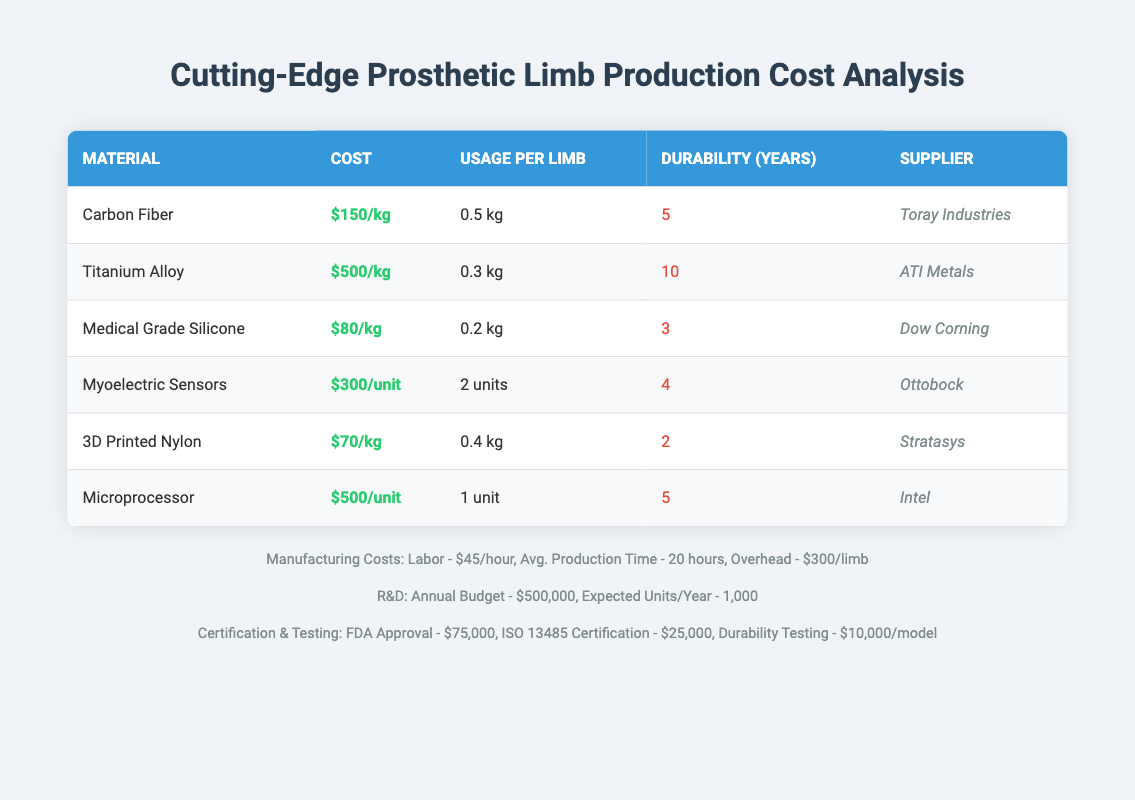What is the cost of Carbon Fiber per kilogram? The table shows that the cost of Carbon Fiber is listed as $150/kg.
Answer: $150/kg How much Medical Grade Silicone is used on average per limb? According to the table, the average usage of Medical Grade Silicone per limb is 0.2 kg.
Answer: 0.2 kg How many units of Myoelectric Sensors are required for each limb? The table indicates that 2 units of Myoelectric Sensors are required for each prosthetic limb.
Answer: 2 units What is the total cost of materials for Titanium Alloy used in one limb? To find the total cost of Titanium Alloy: Cost per kg is $500, and average usage per limb is 0.3 kg, so total cost = 500 * 0.3 = $150.
Answer: $150 What is the total durability in years of all materials used in a single prosthetic limb? To find the total durability, we need to sum the durability of each material used: Carbon Fiber (5) + Titanium Alloy (10) + Medical Grade Silicone (3) + Myoelectric Sensors (4) + 3D Printed Nylon (2) + Microprocessor (5) = 29 years.
Answer: 29 years Do all materials listed have a durability of more than 2 years? Check the durability of each material: Carbon Fiber (5), Titanium Alloy (10), Medical Grade Silicone (3), Myoelectric Sensors (4), 3D Printed Nylon (2), Microprocessor (5). Since 3D Printed Nylon has exactly 2 years, the answer is no.
Answer: No Is the supplier for Microprocessor Intel? The table explicitly lists Intel as the supplier for Microprocessor. Therefore, the statement is true.
Answer: Yes What is the labor cost for manufacturing a single limb? The labor cost per hour is $45, and the average production time is 20 hours, so total labor cost = 45 * 20 = $900.
Answer: $900 If the annual budget for research and development is $500,000, how much budget is allocated per unit if expected units per year is 1,000? To find the budget per unit, divide the annual budget by the expected units: $500,000 / 1,000 = $500.
Answer: $500 